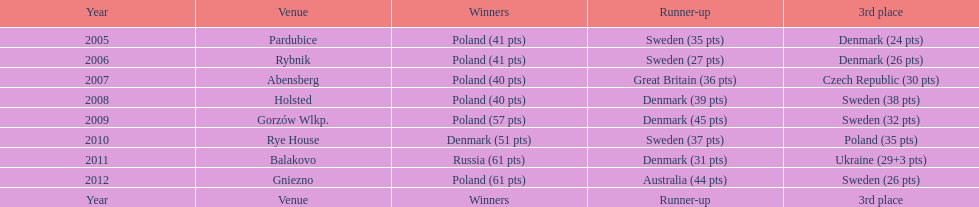What was the variation in the final score between russia and denmark in 2011? 30. 